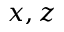Convert formula to latex. <formula><loc_0><loc_0><loc_500><loc_500>x , z</formula> 